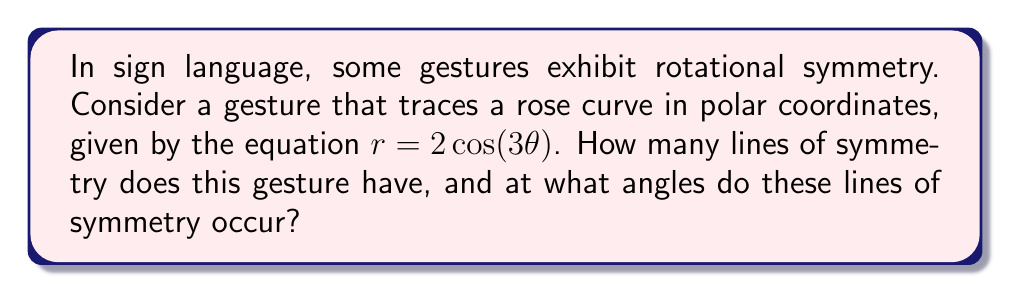Show me your answer to this math problem. To analyze the symmetry of this gesture, we need to examine the properties of the given polar equation:

1) The general equation for a rose curve is $r = a\cos(n\theta)$ or $r = a\sin(n\theta)$, where $n$ determines the number of petals.

2) In this case, we have $r = 2\cos(3\theta)$, so $a = 2$ and $n = 3$.

3) For rose curves:
   - If $n$ is odd, the curve has $2n$ petals.
   - If $n$ is even, the curve has $n$ petals.

4) Here, $n = 3$ (odd), so the curve has $2n = 2(3) = 6$ petals.

5) The number of lines of symmetry in a rose curve is always equal to:
   - $2n$ if $n$ is odd
   - $n$ if $n$ is even

6) Since $n = 3$ (odd), the number of lines of symmetry is $2n = 2(3) = 6$.

7) The angles at which these lines of symmetry occur can be calculated using the formula:
   $$\theta_k = \frac{k\pi}{n}, \text{ where } k = 0, 1, 2, ..., (n-1)$$

8) Substituting $n = 3$ and calculating:
   $$\theta_0 = 0°$$
   $$\theta_1 = 60°$$
   $$\theta_2 = 120°$$

9) Due to the symmetry of the cosine function, these angles repeat in the other three quadrants, giving us all six lines of symmetry at:
   $0°, 60°, 120°, 180°, 240°, 300°$

[asy]
import graph;
size(200);
real r(real t) {return 2*cos(3*t);}
for(int k=0; k<6; ++k) {
  draw(rotate(k*60)*(scale(50)*polar(r,0,2pi)),red);
  draw(rotate(k*30)*(0,100)--rotate(k*30)*(0,-100),blue+dashed);
}
[/asy]
Answer: The gesture has 6 lines of symmetry, occurring at angles $0°, 60°, 120°, 180°, 240°,$ and $300°$. 